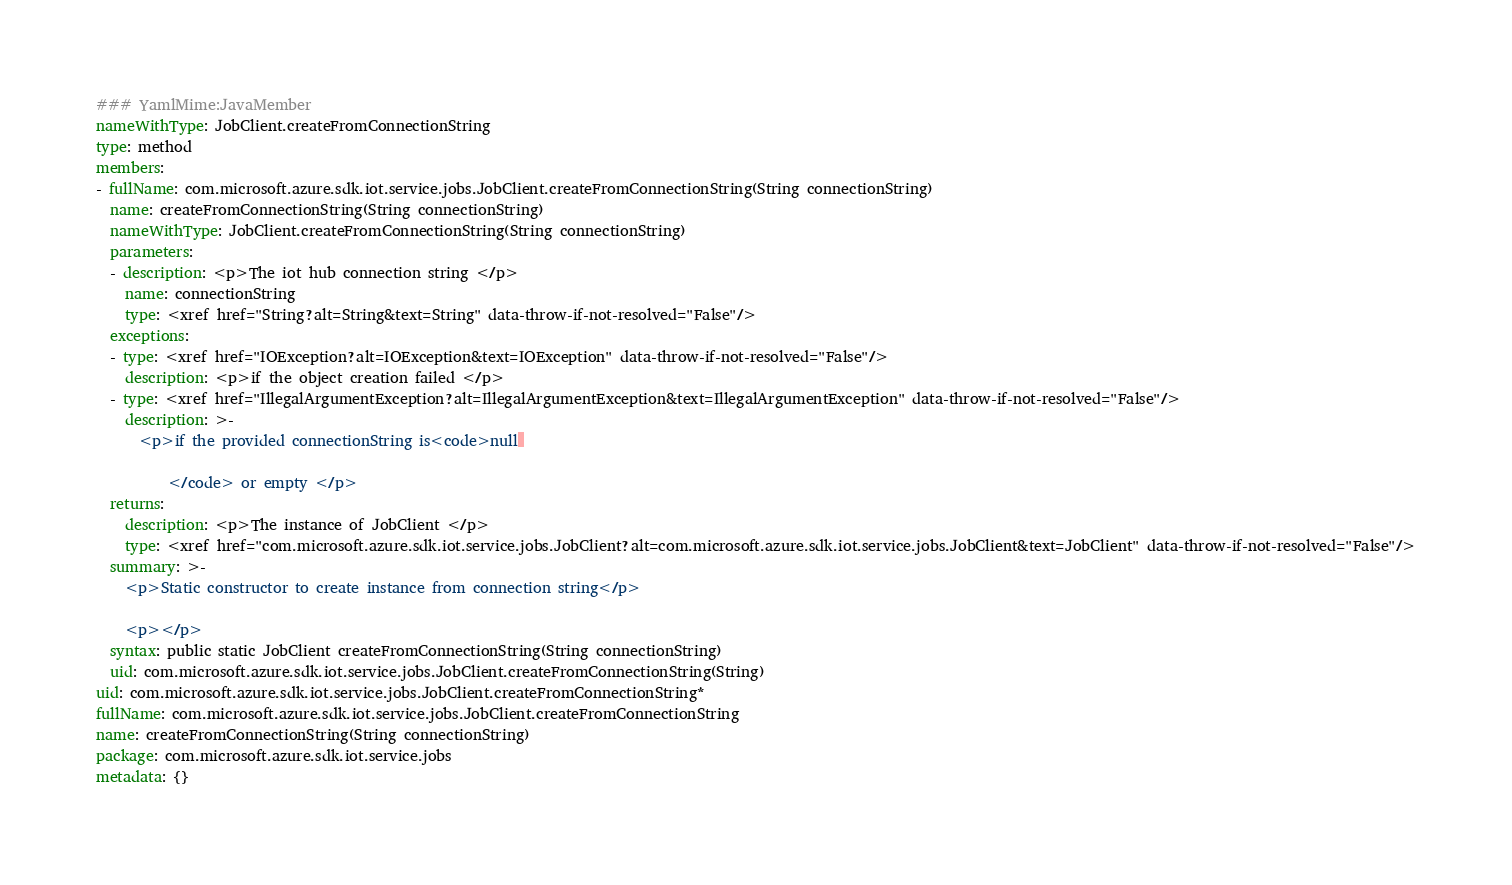<code> <loc_0><loc_0><loc_500><loc_500><_YAML_>### YamlMime:JavaMember
nameWithType: JobClient.createFromConnectionString
type: method
members:
- fullName: com.microsoft.azure.sdk.iot.service.jobs.JobClient.createFromConnectionString(String connectionString)
  name: createFromConnectionString(String connectionString)
  nameWithType: JobClient.createFromConnectionString(String connectionString)
  parameters:
  - description: <p>The iot hub connection string </p>
    name: connectionString
    type: <xref href="String?alt=String&text=String" data-throw-if-not-resolved="False"/>
  exceptions:
  - type: <xref href="IOException?alt=IOException&text=IOException" data-throw-if-not-resolved="False"/>
    description: <p>if the object creation failed </p>
  - type: <xref href="IllegalArgumentException?alt=IllegalArgumentException&text=IllegalArgumentException" data-throw-if-not-resolved="False"/>
    description: >-
      <p>if the provided connectionString is<code>null 

          </code> or empty </p>
  returns:
    description: <p>The instance of JobClient </p>
    type: <xref href="com.microsoft.azure.sdk.iot.service.jobs.JobClient?alt=com.microsoft.azure.sdk.iot.service.jobs.JobClient&text=JobClient" data-throw-if-not-resolved="False"/>
  summary: >-
    <p>Static constructor to create instance from connection string</p>

    <p></p>
  syntax: public static JobClient createFromConnectionString(String connectionString)
  uid: com.microsoft.azure.sdk.iot.service.jobs.JobClient.createFromConnectionString(String)
uid: com.microsoft.azure.sdk.iot.service.jobs.JobClient.createFromConnectionString*
fullName: com.microsoft.azure.sdk.iot.service.jobs.JobClient.createFromConnectionString
name: createFromConnectionString(String connectionString)
package: com.microsoft.azure.sdk.iot.service.jobs
metadata: {}
</code> 